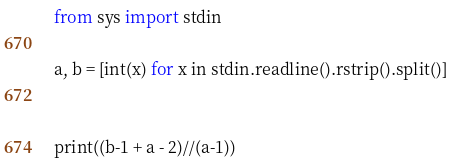<code> <loc_0><loc_0><loc_500><loc_500><_Python_>from sys import stdin

a, b = [int(x) for x in stdin.readline().rstrip().split()]


print((b-1 + a - 2)//(a-1))</code> 